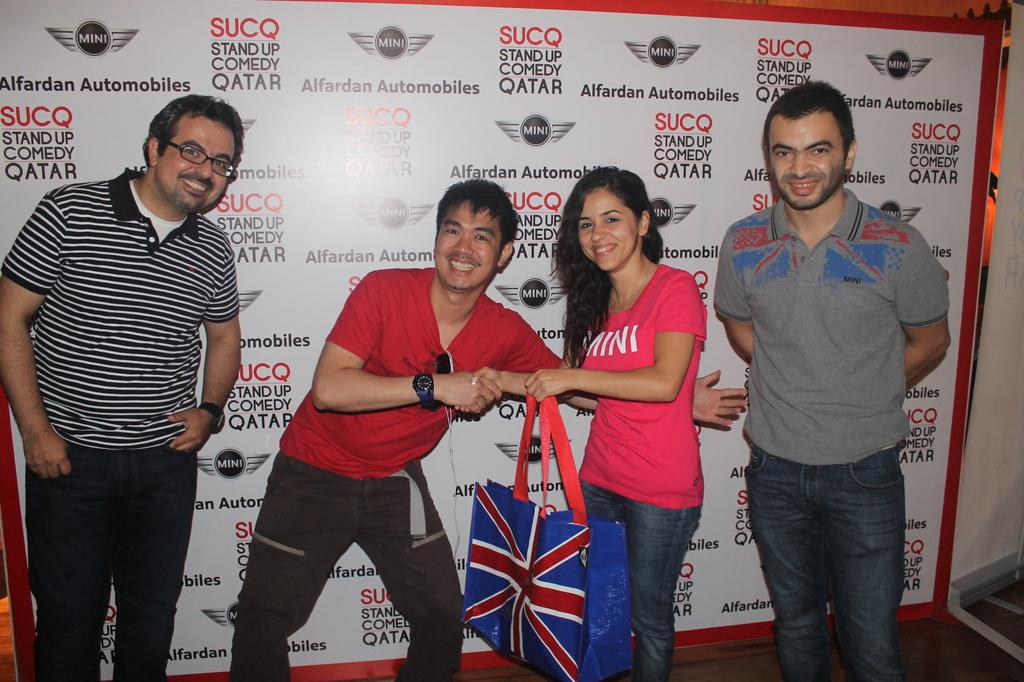What can be seen in the image involving people? There are people standing in the image. What are the people wearing? The people are wearing clothes. Can you identify any accessories worn by the people? Two men in the image are wearing wrist watches. Are there any other notable items visible in the image? One person in the image is wearing spectacles, there is a bag in the image, and there is a poster in the image. What type of grass is growing on the wrist of the person wearing the watch? There is no grass visible in the image; it is focused on people and their accessories. 